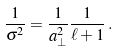<formula> <loc_0><loc_0><loc_500><loc_500>\frac { 1 } { \sigma ^ { 2 } } = \frac { 1 } { a _ { \perp } ^ { 2 } } \frac { 1 } { \ell + 1 } \, .</formula> 